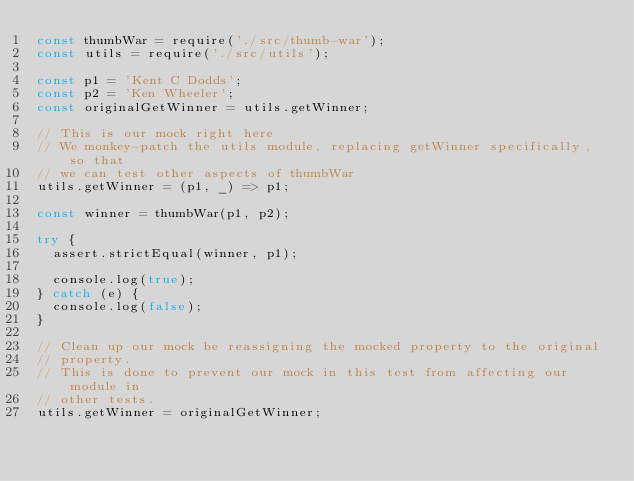<code> <loc_0><loc_0><loc_500><loc_500><_JavaScript_>const thumbWar = require('./src/thumb-war');
const utils = require('./src/utils');

const p1 = 'Kent C Dodds';
const p2 = 'Ken Wheeler';
const originalGetWinner = utils.getWinner;

// This is our mock right here
// We monkey-patch the utils module, replacing getWinner specifically, so that
// we can test other aspects of thumbWar
utils.getWinner = (p1, _) => p1;

const winner = thumbWar(p1, p2);

try {
  assert.strictEqual(winner, p1);

  console.log(true);
} catch (e) {
  console.log(false);
}

// Clean up our mock be reassigning the mocked property to the original
// property.
// This is done to prevent our mock in this test from affecting our module in
// other tests.
utils.getWinner = originalGetWinner;
</code> 